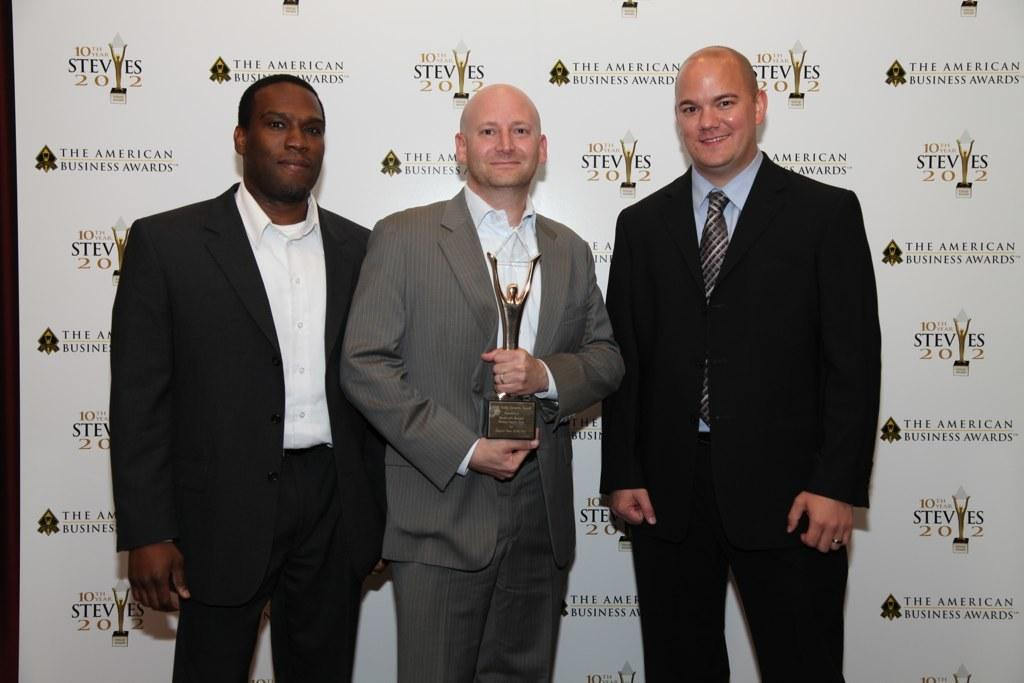How many men are in the foreground of the image? There are three men standing in the foreground of the image. What is one of the men holding? One man is holding an award. What can be seen in the background of the image? There is a banner wall in the background of the image. What type of station is visible in the image? There is no station present in the image. What sign can be seen on the banner wall in the image? The provided facts do not mention any specific signs on the banner wall, so we cannot answer this question definitively. 